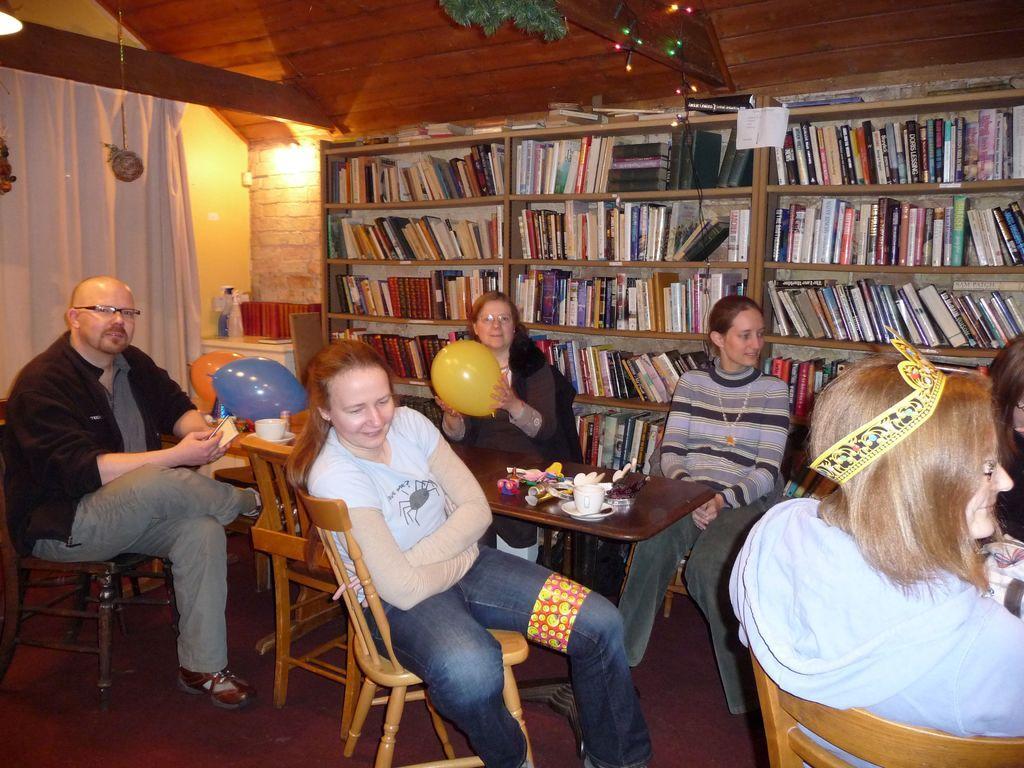Can you describe this image briefly? here we can see a group of people sitting on the chair, and in front there is the table and and some objects on it, and at back there are bookshelves, and here is the light, and here is the curtain. 